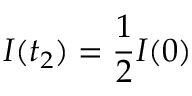<formula> <loc_0><loc_0><loc_500><loc_500>I ( t _ { 2 } ) = \frac { 1 } { 2 } I ( 0 )</formula> 